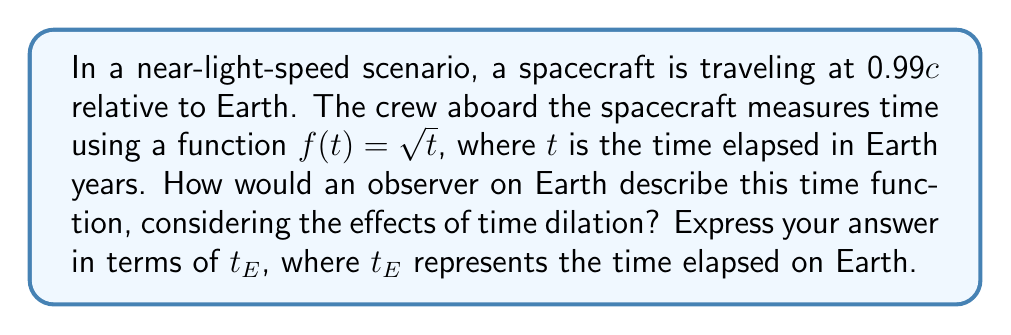Could you help me with this problem? To solve this problem, we need to consider the effects of time dilation as described by Einstein's special relativity. Let's approach this step-by-step:

1) First, recall the time dilation formula:
   $$t' = \frac{t}{\sqrt{1 - \frac{v^2}{c^2}}}$$
   where $t'$ is the time measured on the moving object (spacecraft), $t$ is the time measured by the stationary observer (Earth), $v$ is the relative velocity, and $c$ is the speed of light.

2) Given that the spacecraft is traveling at 0.99c, let's calculate the time dilation factor:
   $$\frac{1}{\sqrt{1 - \frac{(0.99c)^2}{c^2}}} = \frac{1}{\sqrt{1 - 0.9801}} \approx 7.0888$$

3) This means that for every 1 year that passes on the spacecraft, approximately 7.0888 years pass on Earth.

4) Now, let's consider the time function used on the spacecraft: $f(t) = \sqrt{t}$

5) To express this in terms of Earth time ($t_E$), we need to replace $t$ with $\frac{t_E}{7.0888}$:
   $$f(t_E) = \sqrt{\frac{t_E}{7.0888}}$$

6) Simplifying:
   $$f(t_E) = \sqrt{\frac{t_E}{7.0888}} = \frac{\sqrt{t_E}}{\sqrt{7.0888}} \approx 0.3758\sqrt{t_E}$$

Therefore, the time function as observed from Earth would be approximately $0.3758\sqrt{t_E}$.
Answer: $f(t_E) \approx 0.3758\sqrt{t_E}$ 